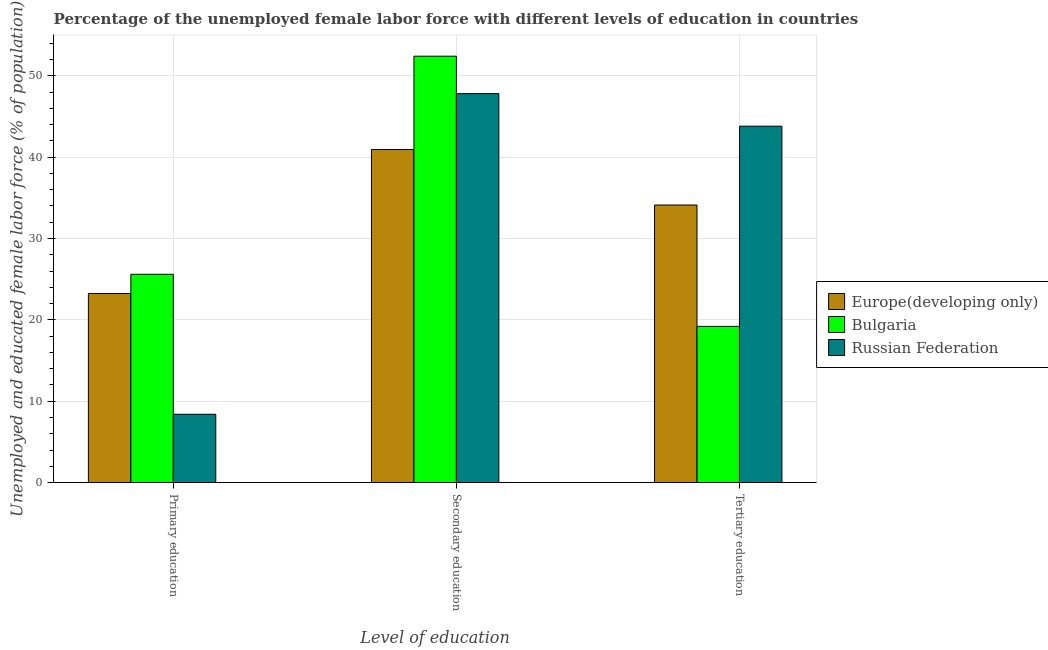How many groups of bars are there?
Provide a short and direct response. 3. What is the label of the 1st group of bars from the left?
Give a very brief answer. Primary education. What is the percentage of female labor force who received tertiary education in Russian Federation?
Your response must be concise. 43.8. Across all countries, what is the maximum percentage of female labor force who received secondary education?
Offer a very short reply. 52.4. Across all countries, what is the minimum percentage of female labor force who received tertiary education?
Ensure brevity in your answer.  19.2. In which country was the percentage of female labor force who received secondary education minimum?
Offer a terse response. Europe(developing only). What is the total percentage of female labor force who received tertiary education in the graph?
Ensure brevity in your answer.  97.11. What is the difference between the percentage of female labor force who received secondary education in Europe(developing only) and that in Bulgaria?
Make the answer very short. -11.47. What is the difference between the percentage of female labor force who received primary education in Europe(developing only) and the percentage of female labor force who received tertiary education in Russian Federation?
Provide a succinct answer. -20.56. What is the average percentage of female labor force who received tertiary education per country?
Provide a short and direct response. 32.37. What is the difference between the percentage of female labor force who received secondary education and percentage of female labor force who received tertiary education in Europe(developing only)?
Your answer should be compact. 6.82. What is the ratio of the percentage of female labor force who received tertiary education in Europe(developing only) to that in Russian Federation?
Give a very brief answer. 0.78. Is the percentage of female labor force who received primary education in Europe(developing only) less than that in Bulgaria?
Provide a short and direct response. Yes. What is the difference between the highest and the second highest percentage of female labor force who received secondary education?
Offer a very short reply. 4.6. What is the difference between the highest and the lowest percentage of female labor force who received secondary education?
Your answer should be compact. 11.47. In how many countries, is the percentage of female labor force who received tertiary education greater than the average percentage of female labor force who received tertiary education taken over all countries?
Your answer should be very brief. 2. Is the sum of the percentage of female labor force who received tertiary education in Bulgaria and Europe(developing only) greater than the maximum percentage of female labor force who received secondary education across all countries?
Your answer should be compact. Yes. What does the 3rd bar from the right in Secondary education represents?
Keep it short and to the point. Europe(developing only). Is it the case that in every country, the sum of the percentage of female labor force who received primary education and percentage of female labor force who received secondary education is greater than the percentage of female labor force who received tertiary education?
Your answer should be compact. Yes. How many bars are there?
Your answer should be compact. 9. Are all the bars in the graph horizontal?
Make the answer very short. No. How many countries are there in the graph?
Keep it short and to the point. 3. What is the difference between two consecutive major ticks on the Y-axis?
Keep it short and to the point. 10. Does the graph contain any zero values?
Give a very brief answer. No. Does the graph contain grids?
Give a very brief answer. Yes. How many legend labels are there?
Make the answer very short. 3. How are the legend labels stacked?
Provide a short and direct response. Vertical. What is the title of the graph?
Your answer should be very brief. Percentage of the unemployed female labor force with different levels of education in countries. Does "Other small states" appear as one of the legend labels in the graph?
Your answer should be compact. No. What is the label or title of the X-axis?
Your answer should be compact. Level of education. What is the label or title of the Y-axis?
Make the answer very short. Unemployed and educated female labor force (% of population). What is the Unemployed and educated female labor force (% of population) of Europe(developing only) in Primary education?
Provide a succinct answer. 23.24. What is the Unemployed and educated female labor force (% of population) of Bulgaria in Primary education?
Provide a succinct answer. 25.6. What is the Unemployed and educated female labor force (% of population) in Russian Federation in Primary education?
Give a very brief answer. 8.4. What is the Unemployed and educated female labor force (% of population) in Europe(developing only) in Secondary education?
Make the answer very short. 40.93. What is the Unemployed and educated female labor force (% of population) in Bulgaria in Secondary education?
Make the answer very short. 52.4. What is the Unemployed and educated female labor force (% of population) in Russian Federation in Secondary education?
Provide a succinct answer. 47.8. What is the Unemployed and educated female labor force (% of population) of Europe(developing only) in Tertiary education?
Ensure brevity in your answer.  34.11. What is the Unemployed and educated female labor force (% of population) of Bulgaria in Tertiary education?
Provide a short and direct response. 19.2. What is the Unemployed and educated female labor force (% of population) of Russian Federation in Tertiary education?
Make the answer very short. 43.8. Across all Level of education, what is the maximum Unemployed and educated female labor force (% of population) of Europe(developing only)?
Your answer should be compact. 40.93. Across all Level of education, what is the maximum Unemployed and educated female labor force (% of population) of Bulgaria?
Keep it short and to the point. 52.4. Across all Level of education, what is the maximum Unemployed and educated female labor force (% of population) of Russian Federation?
Provide a short and direct response. 47.8. Across all Level of education, what is the minimum Unemployed and educated female labor force (% of population) in Europe(developing only)?
Ensure brevity in your answer.  23.24. Across all Level of education, what is the minimum Unemployed and educated female labor force (% of population) of Bulgaria?
Provide a succinct answer. 19.2. Across all Level of education, what is the minimum Unemployed and educated female labor force (% of population) of Russian Federation?
Keep it short and to the point. 8.4. What is the total Unemployed and educated female labor force (% of population) in Europe(developing only) in the graph?
Ensure brevity in your answer.  98.28. What is the total Unemployed and educated female labor force (% of population) in Bulgaria in the graph?
Give a very brief answer. 97.2. What is the total Unemployed and educated female labor force (% of population) in Russian Federation in the graph?
Give a very brief answer. 100. What is the difference between the Unemployed and educated female labor force (% of population) in Europe(developing only) in Primary education and that in Secondary education?
Your answer should be compact. -17.69. What is the difference between the Unemployed and educated female labor force (% of population) of Bulgaria in Primary education and that in Secondary education?
Ensure brevity in your answer.  -26.8. What is the difference between the Unemployed and educated female labor force (% of population) of Russian Federation in Primary education and that in Secondary education?
Make the answer very short. -39.4. What is the difference between the Unemployed and educated female labor force (% of population) of Europe(developing only) in Primary education and that in Tertiary education?
Provide a succinct answer. -10.87. What is the difference between the Unemployed and educated female labor force (% of population) of Bulgaria in Primary education and that in Tertiary education?
Offer a very short reply. 6.4. What is the difference between the Unemployed and educated female labor force (% of population) of Russian Federation in Primary education and that in Tertiary education?
Make the answer very short. -35.4. What is the difference between the Unemployed and educated female labor force (% of population) of Europe(developing only) in Secondary education and that in Tertiary education?
Your answer should be compact. 6.82. What is the difference between the Unemployed and educated female labor force (% of population) of Bulgaria in Secondary education and that in Tertiary education?
Keep it short and to the point. 33.2. What is the difference between the Unemployed and educated female labor force (% of population) in Europe(developing only) in Primary education and the Unemployed and educated female labor force (% of population) in Bulgaria in Secondary education?
Your response must be concise. -29.16. What is the difference between the Unemployed and educated female labor force (% of population) of Europe(developing only) in Primary education and the Unemployed and educated female labor force (% of population) of Russian Federation in Secondary education?
Make the answer very short. -24.56. What is the difference between the Unemployed and educated female labor force (% of population) of Bulgaria in Primary education and the Unemployed and educated female labor force (% of population) of Russian Federation in Secondary education?
Provide a succinct answer. -22.2. What is the difference between the Unemployed and educated female labor force (% of population) of Europe(developing only) in Primary education and the Unemployed and educated female labor force (% of population) of Bulgaria in Tertiary education?
Give a very brief answer. 4.04. What is the difference between the Unemployed and educated female labor force (% of population) of Europe(developing only) in Primary education and the Unemployed and educated female labor force (% of population) of Russian Federation in Tertiary education?
Provide a short and direct response. -20.56. What is the difference between the Unemployed and educated female labor force (% of population) of Bulgaria in Primary education and the Unemployed and educated female labor force (% of population) of Russian Federation in Tertiary education?
Ensure brevity in your answer.  -18.2. What is the difference between the Unemployed and educated female labor force (% of population) of Europe(developing only) in Secondary education and the Unemployed and educated female labor force (% of population) of Bulgaria in Tertiary education?
Provide a short and direct response. 21.73. What is the difference between the Unemployed and educated female labor force (% of population) in Europe(developing only) in Secondary education and the Unemployed and educated female labor force (% of population) in Russian Federation in Tertiary education?
Your answer should be very brief. -2.87. What is the average Unemployed and educated female labor force (% of population) of Europe(developing only) per Level of education?
Your answer should be very brief. 32.76. What is the average Unemployed and educated female labor force (% of population) of Bulgaria per Level of education?
Provide a succinct answer. 32.4. What is the average Unemployed and educated female labor force (% of population) of Russian Federation per Level of education?
Your answer should be very brief. 33.33. What is the difference between the Unemployed and educated female labor force (% of population) in Europe(developing only) and Unemployed and educated female labor force (% of population) in Bulgaria in Primary education?
Ensure brevity in your answer.  -2.36. What is the difference between the Unemployed and educated female labor force (% of population) of Europe(developing only) and Unemployed and educated female labor force (% of population) of Russian Federation in Primary education?
Offer a terse response. 14.84. What is the difference between the Unemployed and educated female labor force (% of population) in Bulgaria and Unemployed and educated female labor force (% of population) in Russian Federation in Primary education?
Your response must be concise. 17.2. What is the difference between the Unemployed and educated female labor force (% of population) of Europe(developing only) and Unemployed and educated female labor force (% of population) of Bulgaria in Secondary education?
Make the answer very short. -11.47. What is the difference between the Unemployed and educated female labor force (% of population) in Europe(developing only) and Unemployed and educated female labor force (% of population) in Russian Federation in Secondary education?
Offer a very short reply. -6.87. What is the difference between the Unemployed and educated female labor force (% of population) of Europe(developing only) and Unemployed and educated female labor force (% of population) of Bulgaria in Tertiary education?
Make the answer very short. 14.91. What is the difference between the Unemployed and educated female labor force (% of population) of Europe(developing only) and Unemployed and educated female labor force (% of population) of Russian Federation in Tertiary education?
Your response must be concise. -9.69. What is the difference between the Unemployed and educated female labor force (% of population) in Bulgaria and Unemployed and educated female labor force (% of population) in Russian Federation in Tertiary education?
Provide a short and direct response. -24.6. What is the ratio of the Unemployed and educated female labor force (% of population) of Europe(developing only) in Primary education to that in Secondary education?
Your response must be concise. 0.57. What is the ratio of the Unemployed and educated female labor force (% of population) in Bulgaria in Primary education to that in Secondary education?
Provide a succinct answer. 0.49. What is the ratio of the Unemployed and educated female labor force (% of population) in Russian Federation in Primary education to that in Secondary education?
Your answer should be compact. 0.18. What is the ratio of the Unemployed and educated female labor force (% of population) in Europe(developing only) in Primary education to that in Tertiary education?
Your answer should be very brief. 0.68. What is the ratio of the Unemployed and educated female labor force (% of population) in Russian Federation in Primary education to that in Tertiary education?
Make the answer very short. 0.19. What is the ratio of the Unemployed and educated female labor force (% of population) of Europe(developing only) in Secondary education to that in Tertiary education?
Offer a very short reply. 1.2. What is the ratio of the Unemployed and educated female labor force (% of population) of Bulgaria in Secondary education to that in Tertiary education?
Provide a succinct answer. 2.73. What is the ratio of the Unemployed and educated female labor force (% of population) in Russian Federation in Secondary education to that in Tertiary education?
Keep it short and to the point. 1.09. What is the difference between the highest and the second highest Unemployed and educated female labor force (% of population) in Europe(developing only)?
Make the answer very short. 6.82. What is the difference between the highest and the second highest Unemployed and educated female labor force (% of population) in Bulgaria?
Offer a terse response. 26.8. What is the difference between the highest and the lowest Unemployed and educated female labor force (% of population) of Europe(developing only)?
Offer a very short reply. 17.69. What is the difference between the highest and the lowest Unemployed and educated female labor force (% of population) of Bulgaria?
Make the answer very short. 33.2. What is the difference between the highest and the lowest Unemployed and educated female labor force (% of population) in Russian Federation?
Your answer should be compact. 39.4. 